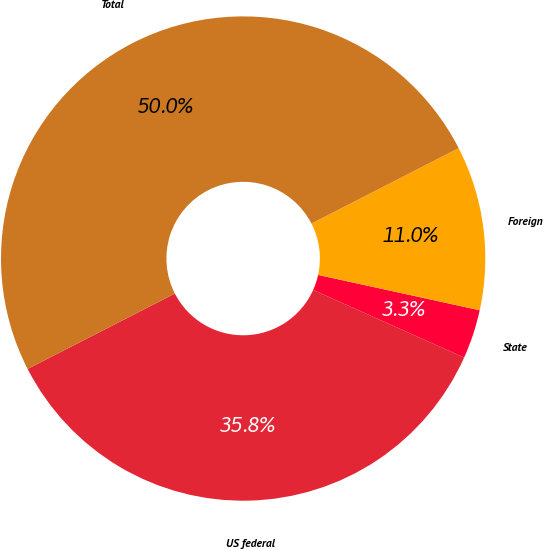Convert chart. <chart><loc_0><loc_0><loc_500><loc_500><pie_chart><fcel>US federal<fcel>State<fcel>Foreign<fcel>Total<nl><fcel>35.76%<fcel>3.28%<fcel>10.96%<fcel>50.0%<nl></chart> 